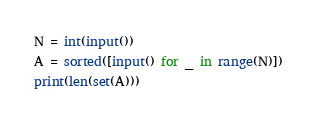<code> <loc_0><loc_0><loc_500><loc_500><_Python_>N = int(input())
A = sorted([input() for _ in range(N)])
print(len(set(A)))
</code> 